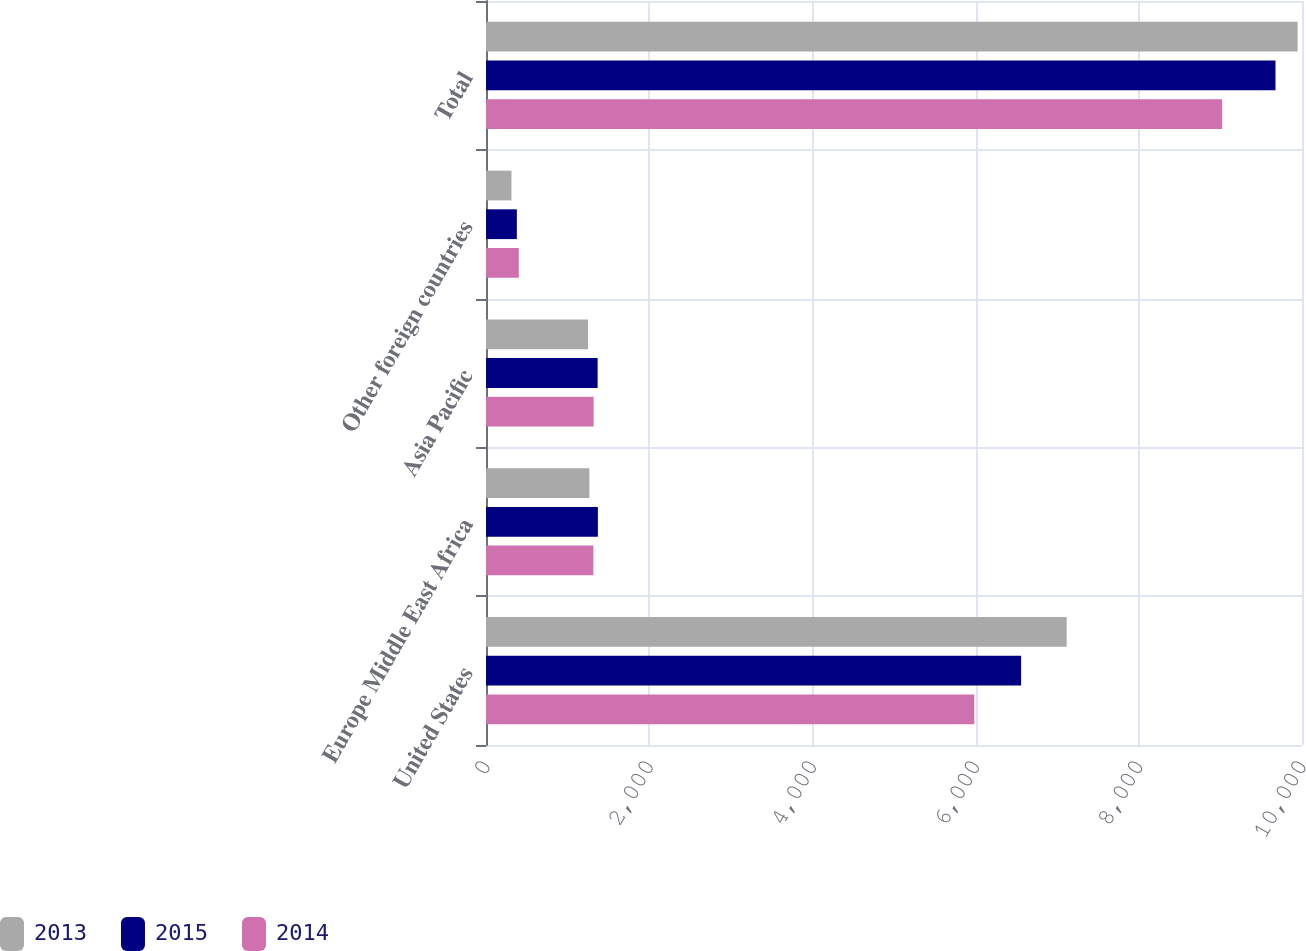Convert chart. <chart><loc_0><loc_0><loc_500><loc_500><stacked_bar_chart><ecel><fcel>United States<fcel>Europe Middle East Africa<fcel>Asia Pacific<fcel>Other foreign countries<fcel>Total<nl><fcel>2013<fcel>7116<fcel>1267<fcel>1251<fcel>312<fcel>9946<nl><fcel>2015<fcel>6558<fcel>1371<fcel>1368<fcel>378<fcel>9675<nl><fcel>2014<fcel>5984<fcel>1316<fcel>1319<fcel>402<fcel>9021<nl></chart> 